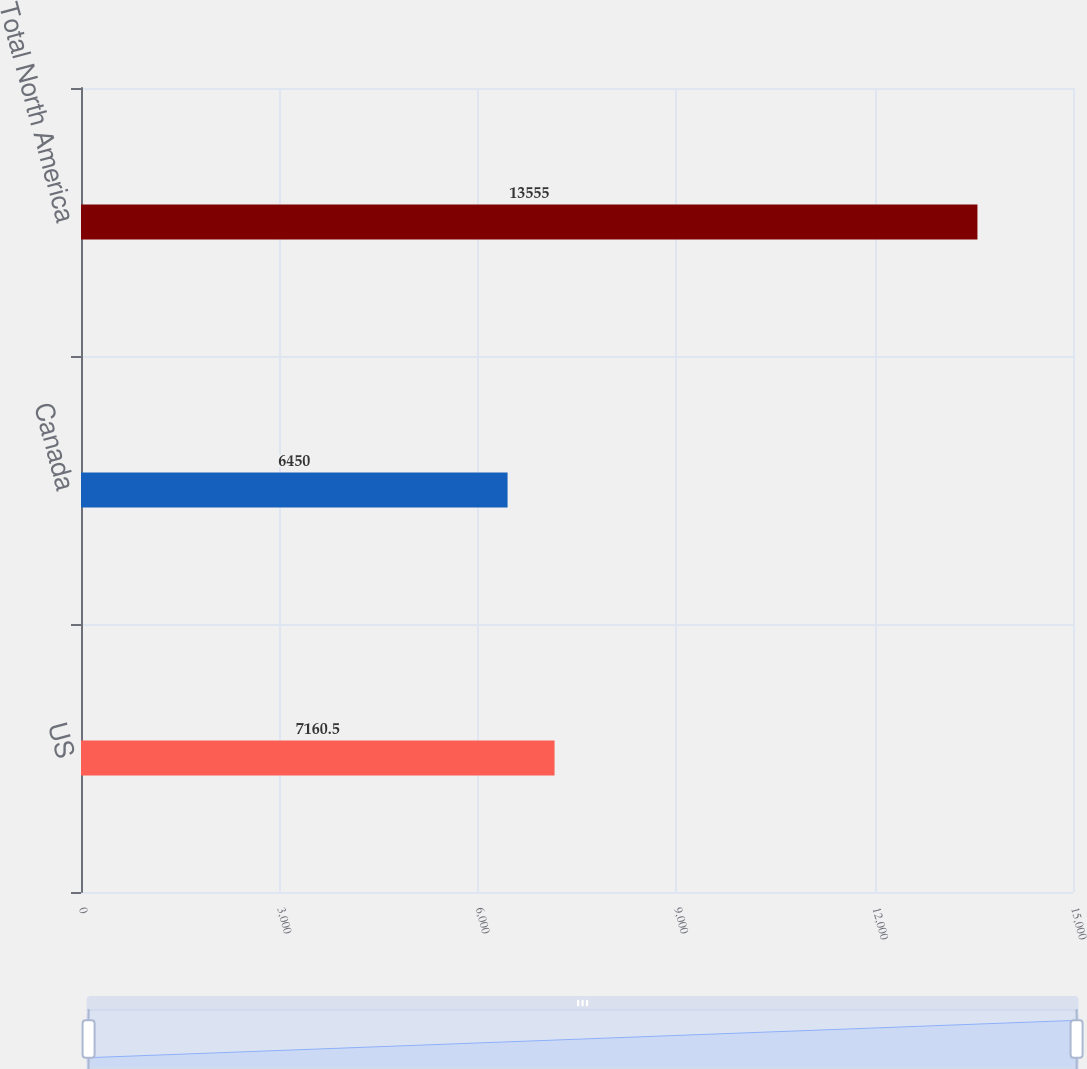Convert chart to OTSL. <chart><loc_0><loc_0><loc_500><loc_500><bar_chart><fcel>US<fcel>Canada<fcel>Total North America<nl><fcel>7160.5<fcel>6450<fcel>13555<nl></chart> 